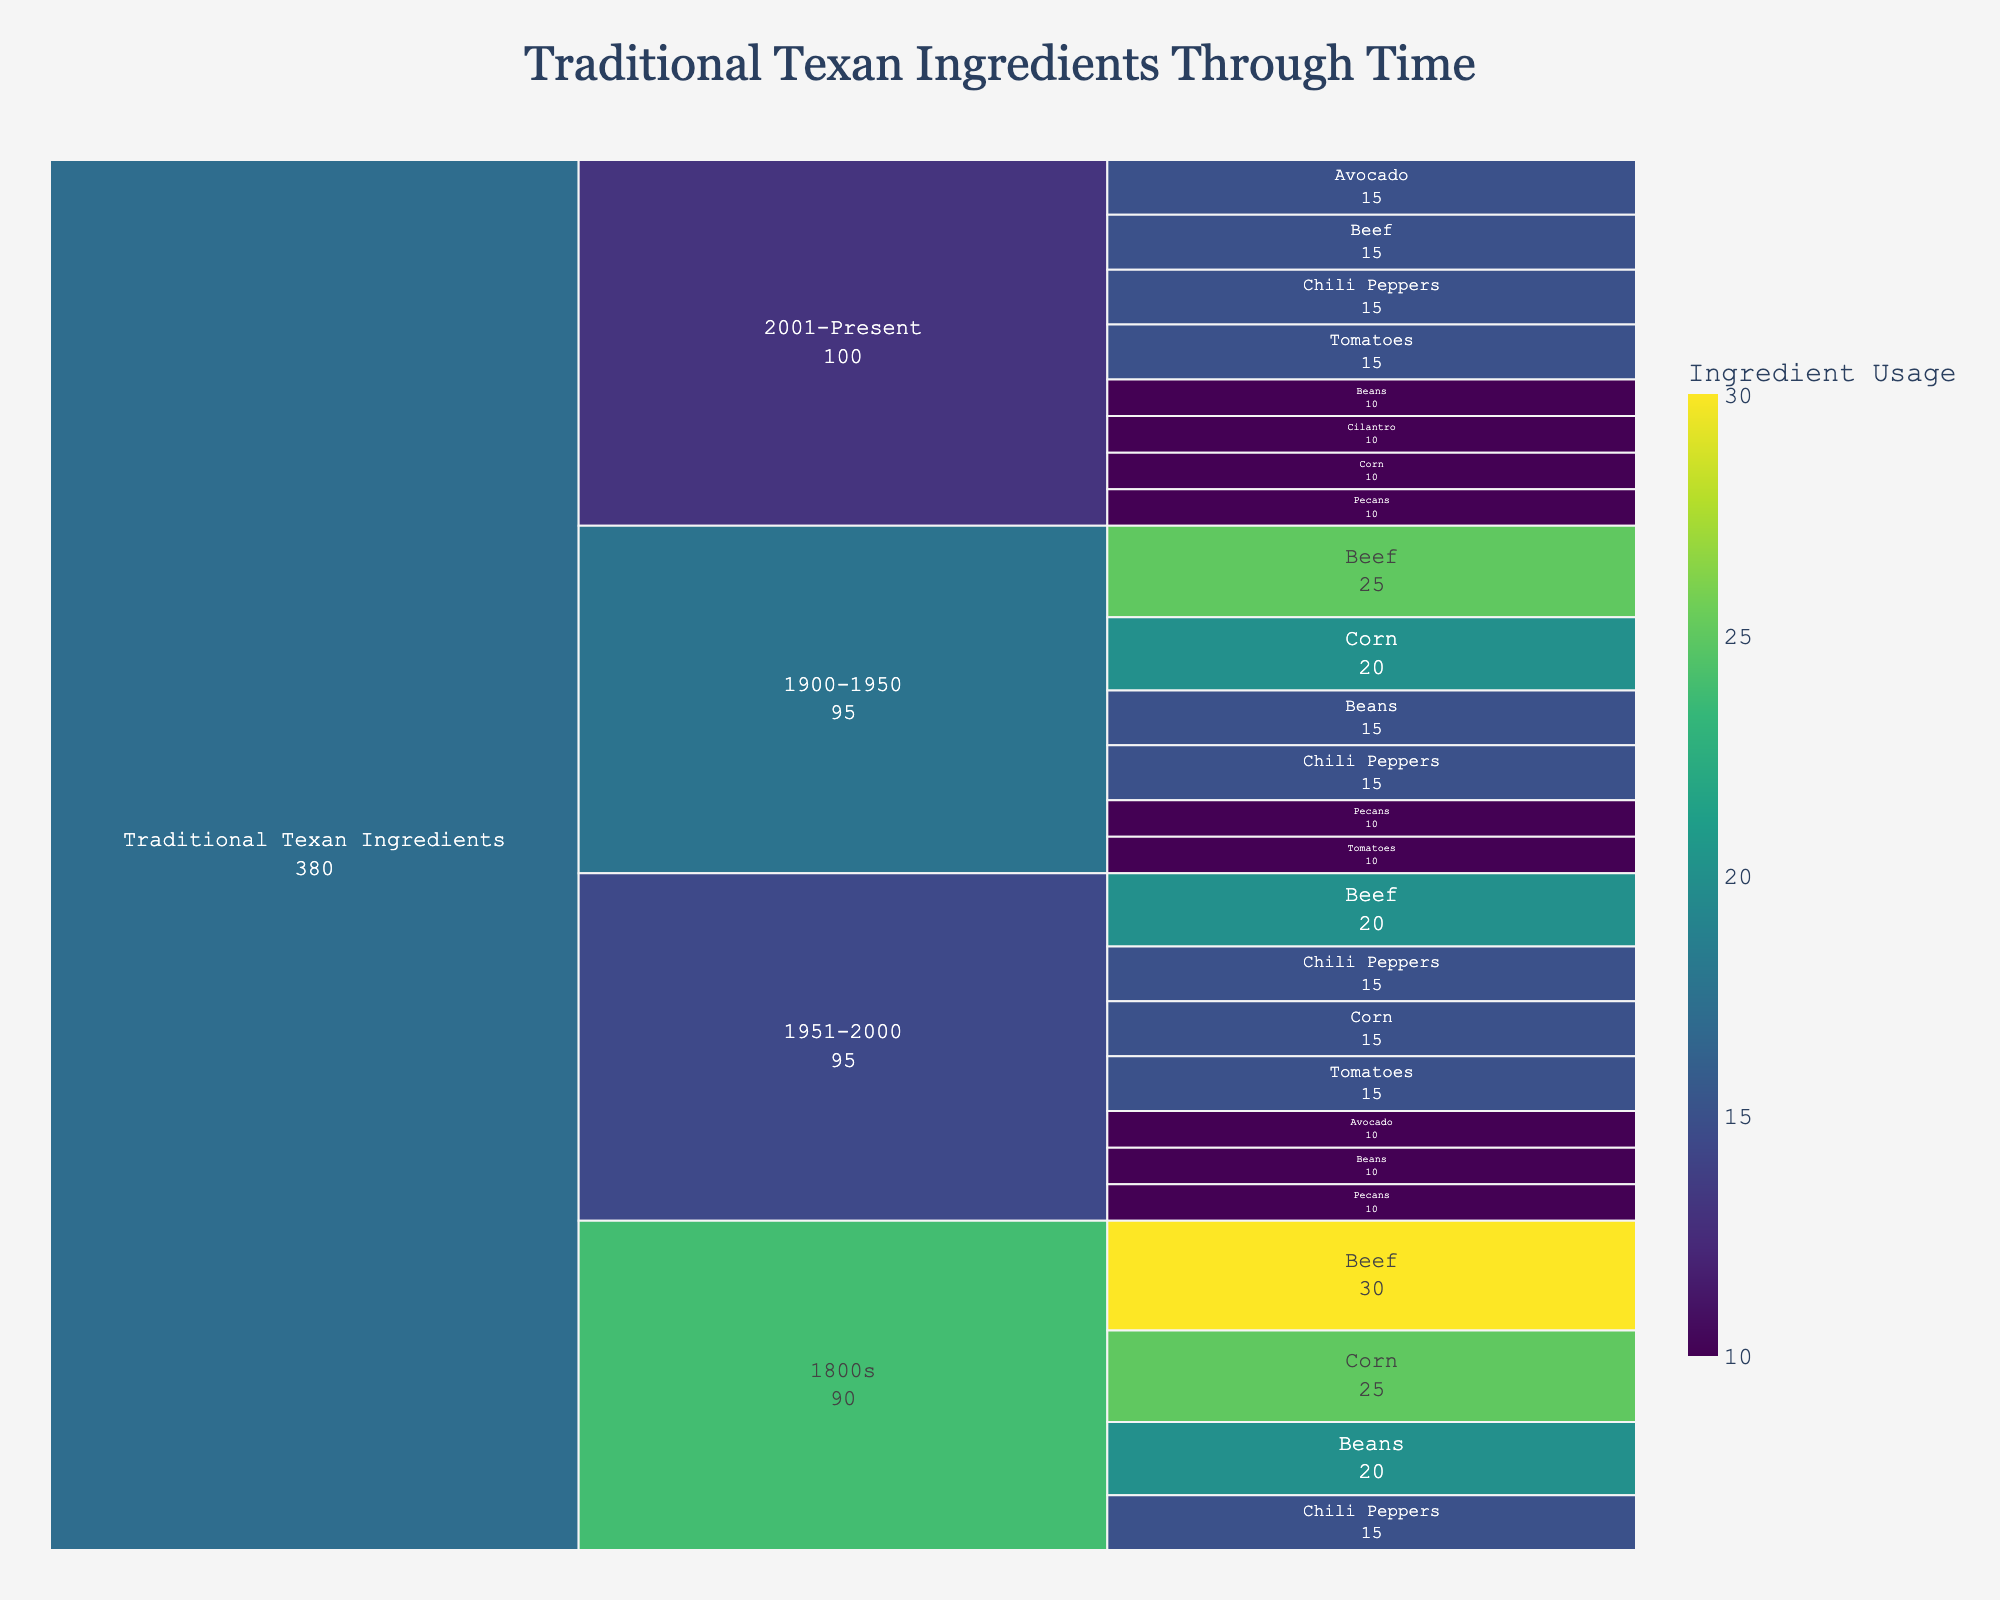What's the total value of Beef usage across all time periods? First, locate Beef usage in all time periods: 1800s (30), 1900-1950 (25), 1951-2000 (20), and 2001-Present (15). Sum these values: 30 + 25 + 20 + 15 = 90.
Answer: 90 Which ingredient had the highest usage value in the 1800s? Check the values for all ingredients in the 1800s: Beef (30), Corn (25), Beans (20), and Chili Peppers (15). Beef has the highest value of 30.
Answer: Beef How does the usage of Avocado in the 1951-2000 period compare to the 2001-Present period? Compare the values: Avocado in the 1951-2000 period is 10, while in the 2001-Present period, it is 15. 15 is greater than 10.
Answer: Greater What's the combined value of Corn and Beans in the 2001-Present period? Corn has a value of 10 and Beans has 10 in the 2001-Present period. Sum these values: 10 + 10 = 20.
Answer: 20 Which ingredient appears in all four time periods? Scan the list of ingredients for each time period. Only Beef, Corn, Beans, and Chili Peppers appear in every period.
Answer: Beef, Corn, Beans, Chili Peppers Has the usage of Beans increased or decreased from the 1800s to the 2001-Present period? Compare the Beans' values from 1800s (20) to 2001-Present (10). The value decreases from 20 to 10.
Answer: Decreased What is the overall trend in Beef usage from the 1800s to the present? The Beef values over time are: 1800s (30), 1900-1950 (25), 1951-2000 (20), and 2001-Present (15). It shows a decreasing trend.
Answer: Decreasing What percentage of total Pecans usage occurred in the 1900-1950 period? First, find Pecans' values: 1900-1950 (10), 1951-2000 (10), and 2001-Present (10). The total is 10 + 10 + 10 = 30. The percentage for 1900-1950 is (10/30) * 100% = 33.33%.
Answer: 33.33% Which new ingredients were introduced in the 2001-Present period? The new ingredients in the 2001-Present period are Avocado and Cilantro, compared to the prior periods.
Answer: Avocado, Cilantro 